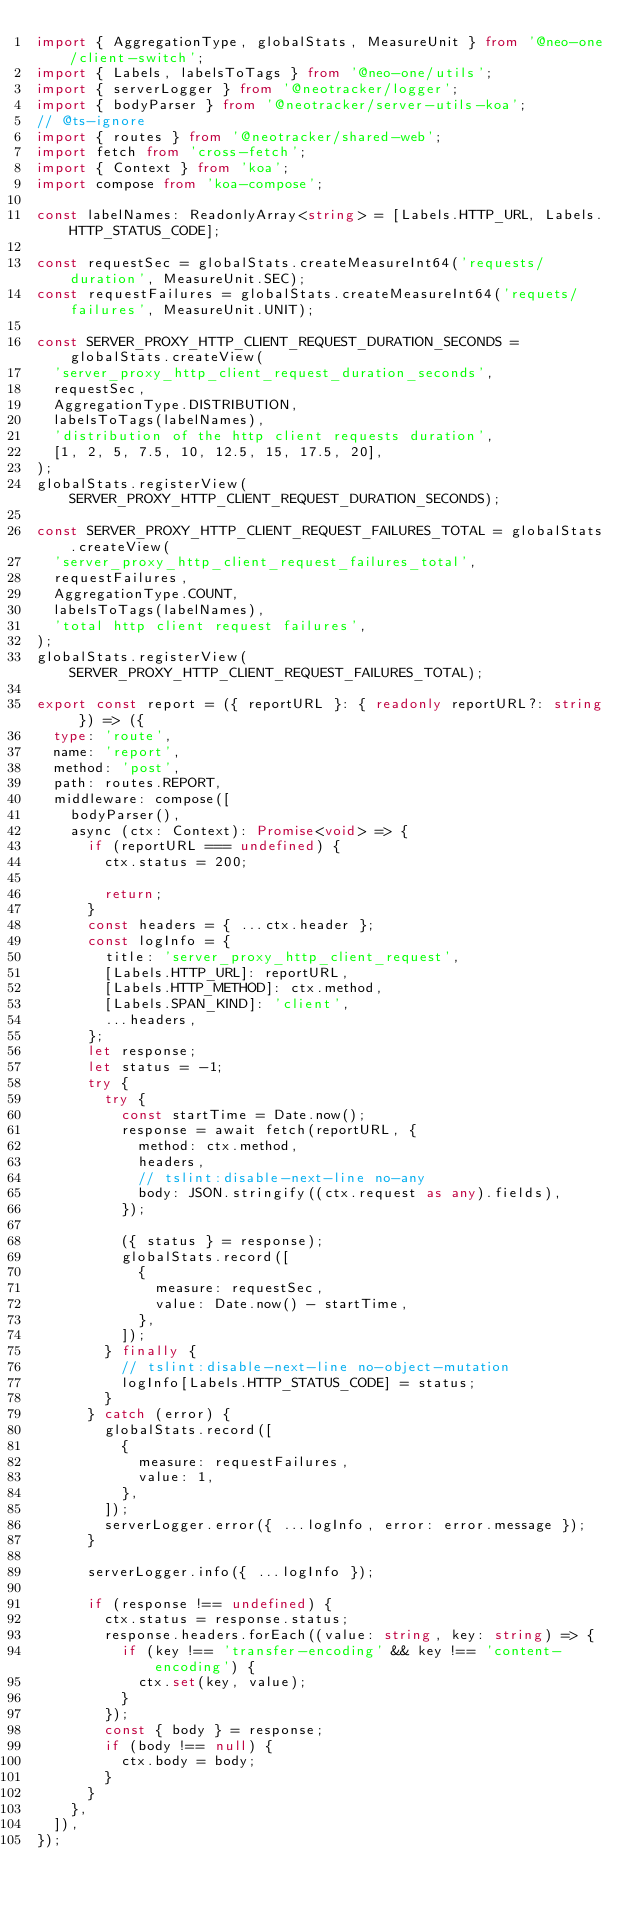<code> <loc_0><loc_0><loc_500><loc_500><_TypeScript_>import { AggregationType, globalStats, MeasureUnit } from '@neo-one/client-switch';
import { Labels, labelsToTags } from '@neo-one/utils';
import { serverLogger } from '@neotracker/logger';
import { bodyParser } from '@neotracker/server-utils-koa';
// @ts-ignore
import { routes } from '@neotracker/shared-web';
import fetch from 'cross-fetch';
import { Context } from 'koa';
import compose from 'koa-compose';

const labelNames: ReadonlyArray<string> = [Labels.HTTP_URL, Labels.HTTP_STATUS_CODE];

const requestSec = globalStats.createMeasureInt64('requests/duration', MeasureUnit.SEC);
const requestFailures = globalStats.createMeasureInt64('requets/failures', MeasureUnit.UNIT);

const SERVER_PROXY_HTTP_CLIENT_REQUEST_DURATION_SECONDS = globalStats.createView(
  'server_proxy_http_client_request_duration_seconds',
  requestSec,
  AggregationType.DISTRIBUTION,
  labelsToTags(labelNames),
  'distribution of the http client requests duration',
  [1, 2, 5, 7.5, 10, 12.5, 15, 17.5, 20],
);
globalStats.registerView(SERVER_PROXY_HTTP_CLIENT_REQUEST_DURATION_SECONDS);

const SERVER_PROXY_HTTP_CLIENT_REQUEST_FAILURES_TOTAL = globalStats.createView(
  'server_proxy_http_client_request_failures_total',
  requestFailures,
  AggregationType.COUNT,
  labelsToTags(labelNames),
  'total http client request failures',
);
globalStats.registerView(SERVER_PROXY_HTTP_CLIENT_REQUEST_FAILURES_TOTAL);

export const report = ({ reportURL }: { readonly reportURL?: string }) => ({
  type: 'route',
  name: 'report',
  method: 'post',
  path: routes.REPORT,
  middleware: compose([
    bodyParser(),
    async (ctx: Context): Promise<void> => {
      if (reportURL === undefined) {
        ctx.status = 200;

        return;
      }
      const headers = { ...ctx.header };
      const logInfo = {
        title: 'server_proxy_http_client_request',
        [Labels.HTTP_URL]: reportURL,
        [Labels.HTTP_METHOD]: ctx.method,
        [Labels.SPAN_KIND]: 'client',
        ...headers,
      };
      let response;
      let status = -1;
      try {
        try {
          const startTime = Date.now();
          response = await fetch(reportURL, {
            method: ctx.method,
            headers,
            // tslint:disable-next-line no-any
            body: JSON.stringify((ctx.request as any).fields),
          });

          ({ status } = response);
          globalStats.record([
            {
              measure: requestSec,
              value: Date.now() - startTime,
            },
          ]);
        } finally {
          // tslint:disable-next-line no-object-mutation
          logInfo[Labels.HTTP_STATUS_CODE] = status;
        }
      } catch (error) {
        globalStats.record([
          {
            measure: requestFailures,
            value: 1,
          },
        ]);
        serverLogger.error({ ...logInfo, error: error.message });
      }

      serverLogger.info({ ...logInfo });

      if (response !== undefined) {
        ctx.status = response.status;
        response.headers.forEach((value: string, key: string) => {
          if (key !== 'transfer-encoding' && key !== 'content-encoding') {
            ctx.set(key, value);
          }
        });
        const { body } = response;
        if (body !== null) {
          ctx.body = body;
        }
      }
    },
  ]),
});
</code> 